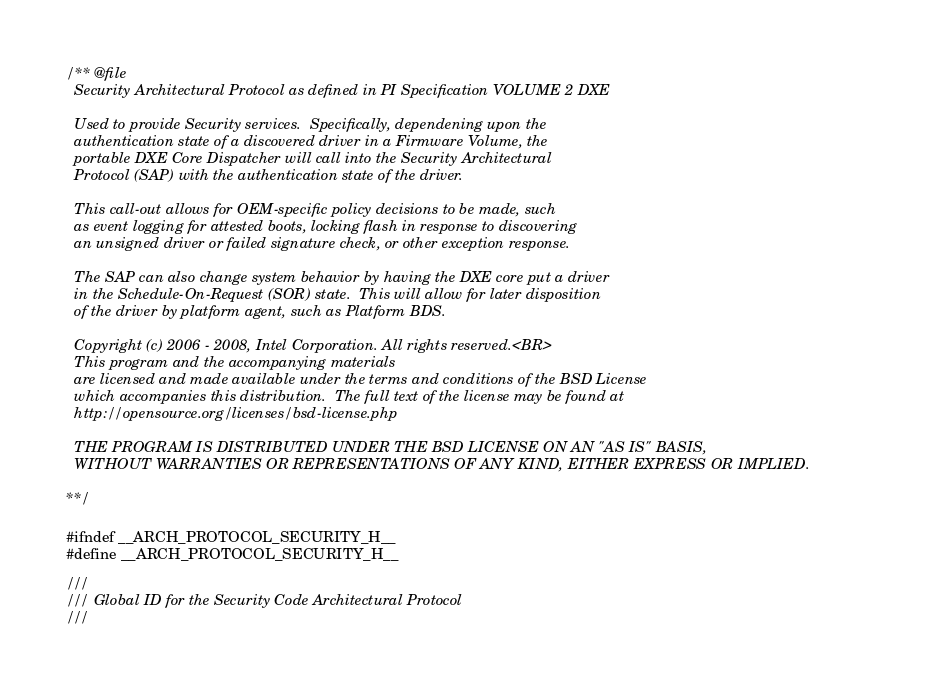<code> <loc_0><loc_0><loc_500><loc_500><_C_>/** @file
  Security Architectural Protocol as defined in PI Specification VOLUME 2 DXE

  Used to provide Security services.  Specifically, dependening upon the 
  authentication state of a discovered driver in a Firmware Volume, the 
  portable DXE Core Dispatcher will call into the Security Architectural 
  Protocol (SAP) with the authentication state of the driver.

  This call-out allows for OEM-specific policy decisions to be made, such
  as event logging for attested boots, locking flash in response to discovering
  an unsigned driver or failed signature check, or other exception response.

  The SAP can also change system behavior by having the DXE core put a driver
  in the Schedule-On-Request (SOR) state.  This will allow for later disposition 
  of the driver by platform agent, such as Platform BDS.

  Copyright (c) 2006 - 2008, Intel Corporation. All rights reserved.<BR>
  This program and the accompanying materials                          
  are licensed and made available under the terms and conditions of the BSD License         
  which accompanies this distribution.  The full text of the license may be found at        
  http://opensource.org/licenses/bsd-license.php                                            

  THE PROGRAM IS DISTRIBUTED UNDER THE BSD LICENSE ON AN "AS IS" BASIS,                     
  WITHOUT WARRANTIES OR REPRESENTATIONS OF ANY KIND, EITHER EXPRESS OR IMPLIED.             

**/

#ifndef __ARCH_PROTOCOL_SECURITY_H__
#define __ARCH_PROTOCOL_SECURITY_H__

///
/// Global ID for the Security Code Architectural Protocol
///</code> 